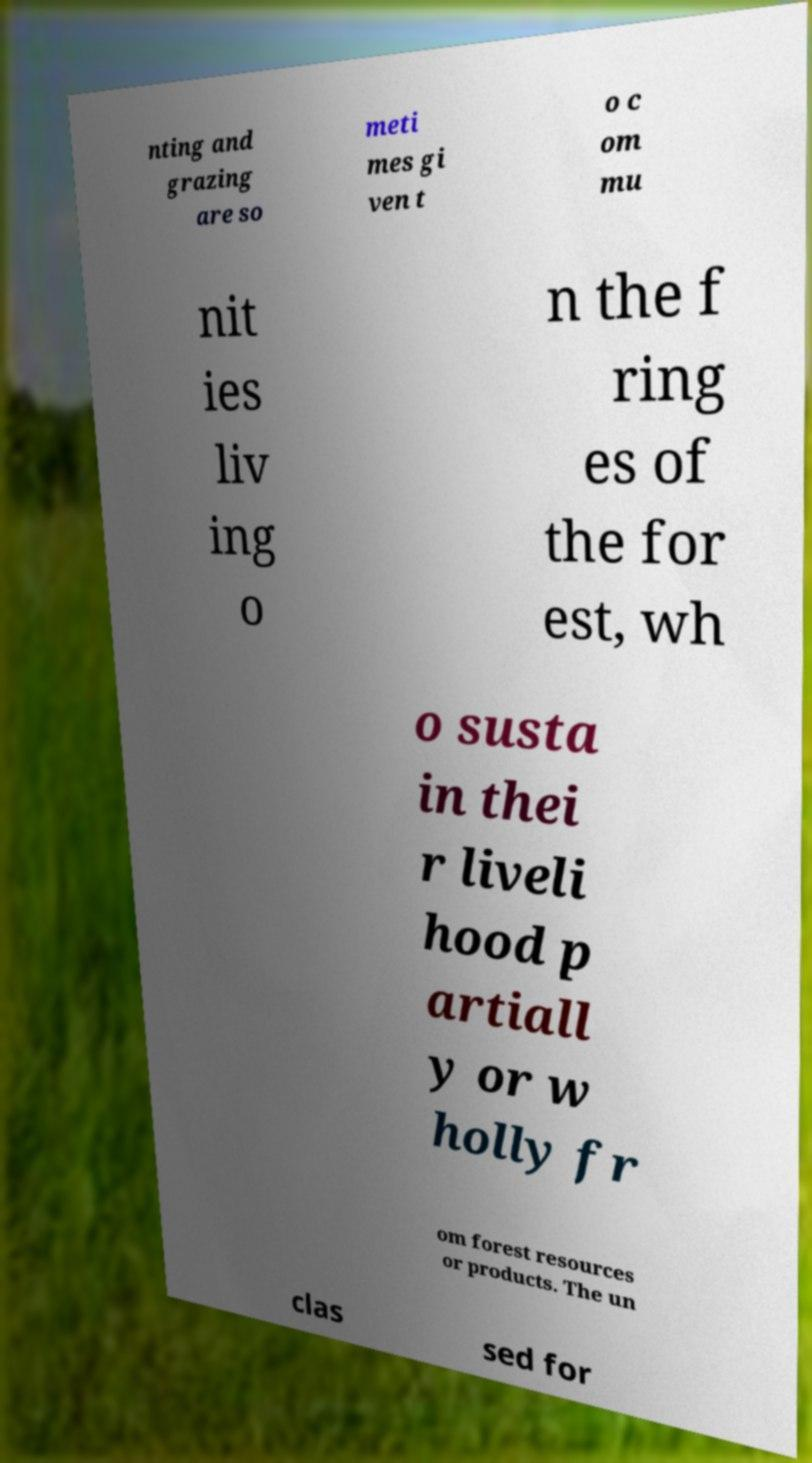Can you read and provide the text displayed in the image?This photo seems to have some interesting text. Can you extract and type it out for me? nting and grazing are so meti mes gi ven t o c om mu nit ies liv ing o n the f ring es of the for est, wh o susta in thei r liveli hood p artiall y or w holly fr om forest resources or products. The un clas sed for 